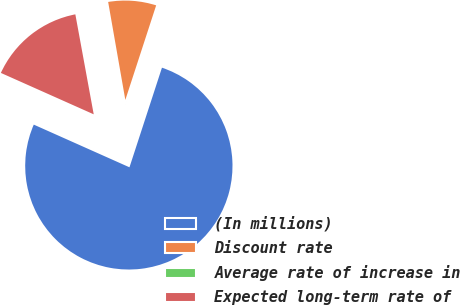Convert chart to OTSL. <chart><loc_0><loc_0><loc_500><loc_500><pie_chart><fcel>(In millions)<fcel>Discount rate<fcel>Average rate of increase in<fcel>Expected long-term rate of<nl><fcel>76.66%<fcel>7.78%<fcel>0.13%<fcel>15.43%<nl></chart> 